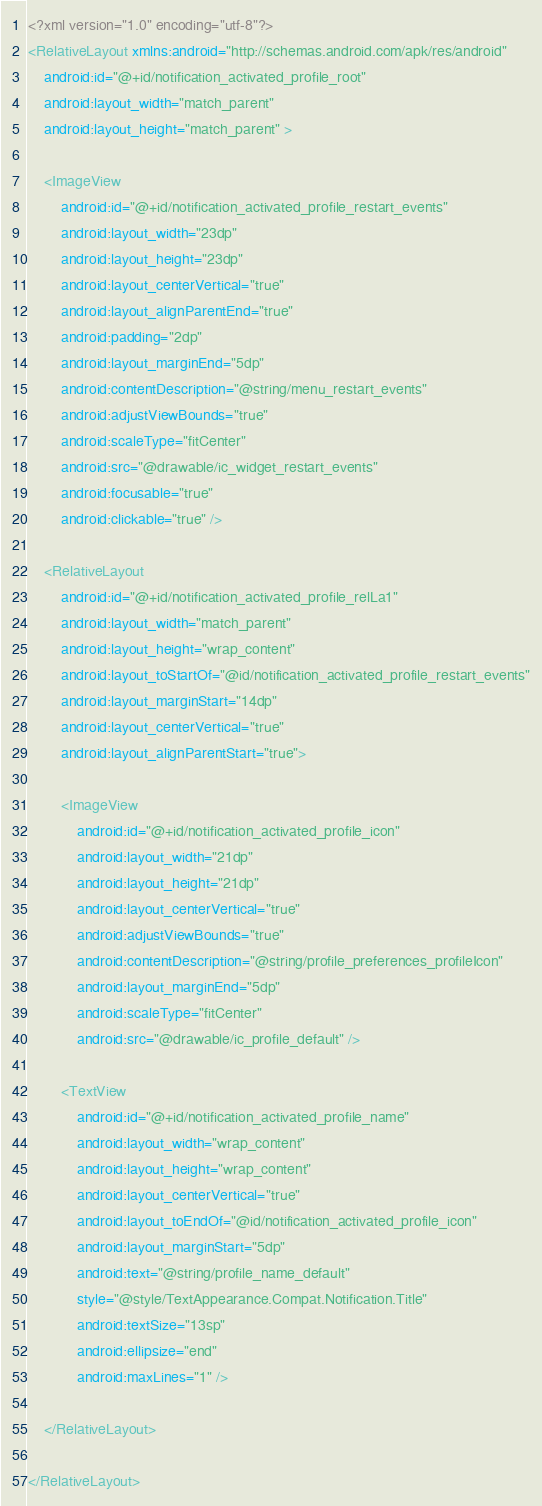Convert code to text. <code><loc_0><loc_0><loc_500><loc_500><_XML_><?xml version="1.0" encoding="utf-8"?>
<RelativeLayout xmlns:android="http://schemas.android.com/apk/res/android"
    android:id="@+id/notification_activated_profile_root"
    android:layout_width="match_parent"
    android:layout_height="match_parent" >

    <ImageView
        android:id="@+id/notification_activated_profile_restart_events"
        android:layout_width="23dp"
        android:layout_height="23dp"
        android:layout_centerVertical="true"
        android:layout_alignParentEnd="true"
        android:padding="2dp"
        android:layout_marginEnd="5dp"
        android:contentDescription="@string/menu_restart_events"
        android:adjustViewBounds="true"
        android:scaleType="fitCenter"
        android:src="@drawable/ic_widget_restart_events"
        android:focusable="true"
        android:clickable="true" />

    <RelativeLayout
        android:id="@+id/notification_activated_profile_relLa1"
        android:layout_width="match_parent"
        android:layout_height="wrap_content"
        android:layout_toStartOf="@id/notification_activated_profile_restart_events"
        android:layout_marginStart="14dp"
        android:layout_centerVertical="true"
        android:layout_alignParentStart="true">

        <ImageView
            android:id="@+id/notification_activated_profile_icon"
            android:layout_width="21dp"
            android:layout_height="21dp"
            android:layout_centerVertical="true"
            android:adjustViewBounds="true"
            android:contentDescription="@string/profile_preferences_profileIcon"
            android:layout_marginEnd="5dp"
            android:scaleType="fitCenter"
            android:src="@drawable/ic_profile_default" />

        <TextView
            android:id="@+id/notification_activated_profile_name"
            android:layout_width="wrap_content"
            android:layout_height="wrap_content"
            android:layout_centerVertical="true"
            android:layout_toEndOf="@id/notification_activated_profile_icon"
            android:layout_marginStart="5dp"
            android:text="@string/profile_name_default"
            style="@style/TextAppearance.Compat.Notification.Title"
            android:textSize="13sp"
            android:ellipsize="end"
            android:maxLines="1" />

    </RelativeLayout>

</RelativeLayout>
</code> 